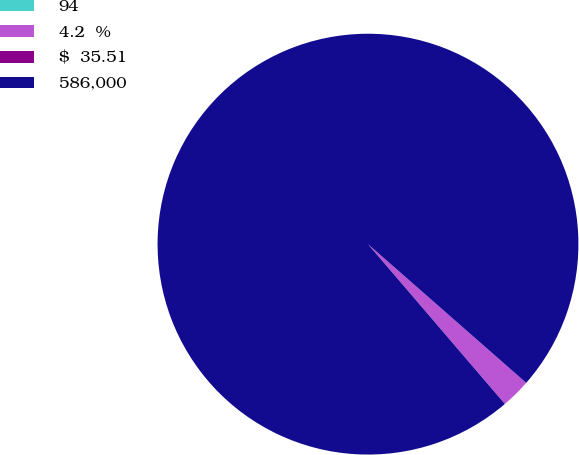Convert chart. <chart><loc_0><loc_0><loc_500><loc_500><pie_chart><fcel>94<fcel>4.2  %<fcel>$  35.51<fcel>586,000<nl><fcel>0.0%<fcel>2.27%<fcel>0.0%<fcel>97.73%<nl></chart> 